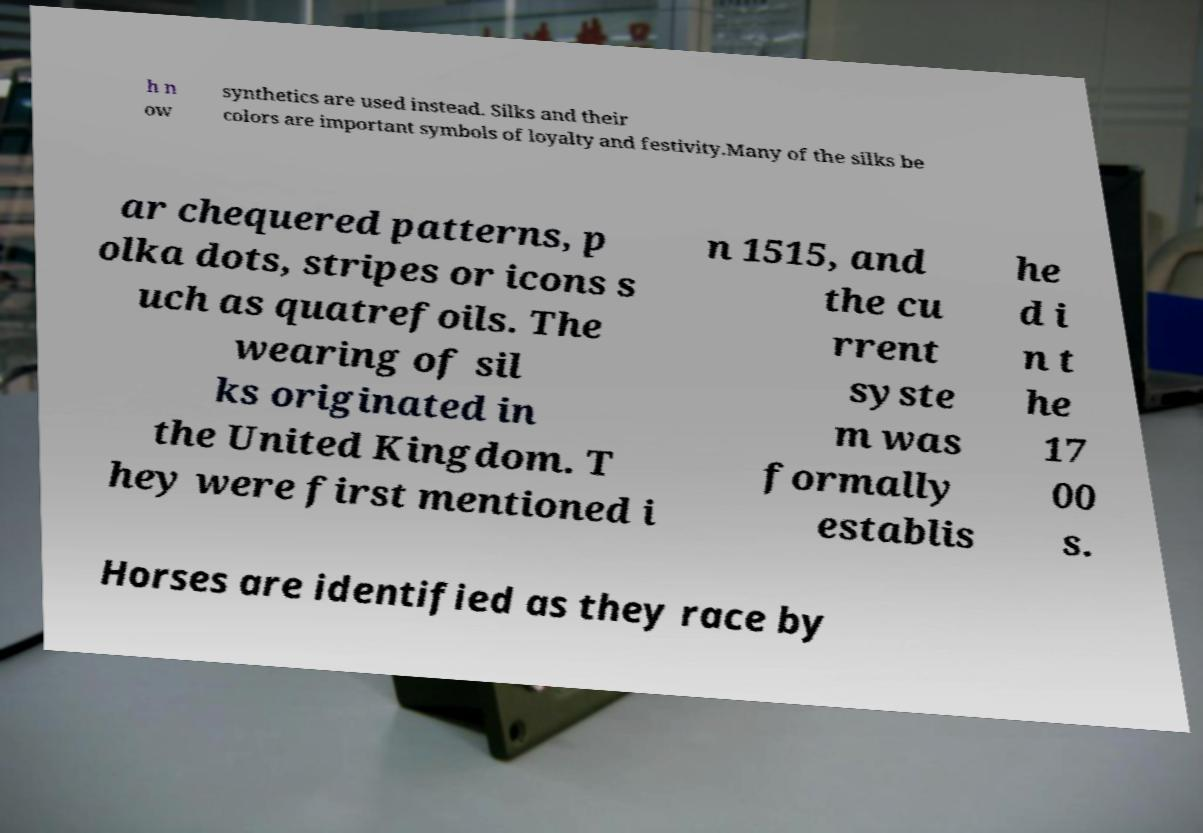Could you extract and type out the text from this image? h n ow synthetics are used instead. Silks and their colors are important symbols of loyalty and festivity.Many of the silks be ar chequered patterns, p olka dots, stripes or icons s uch as quatrefoils. The wearing of sil ks originated in the United Kingdom. T hey were first mentioned i n 1515, and the cu rrent syste m was formally establis he d i n t he 17 00 s. Horses are identified as they race by 